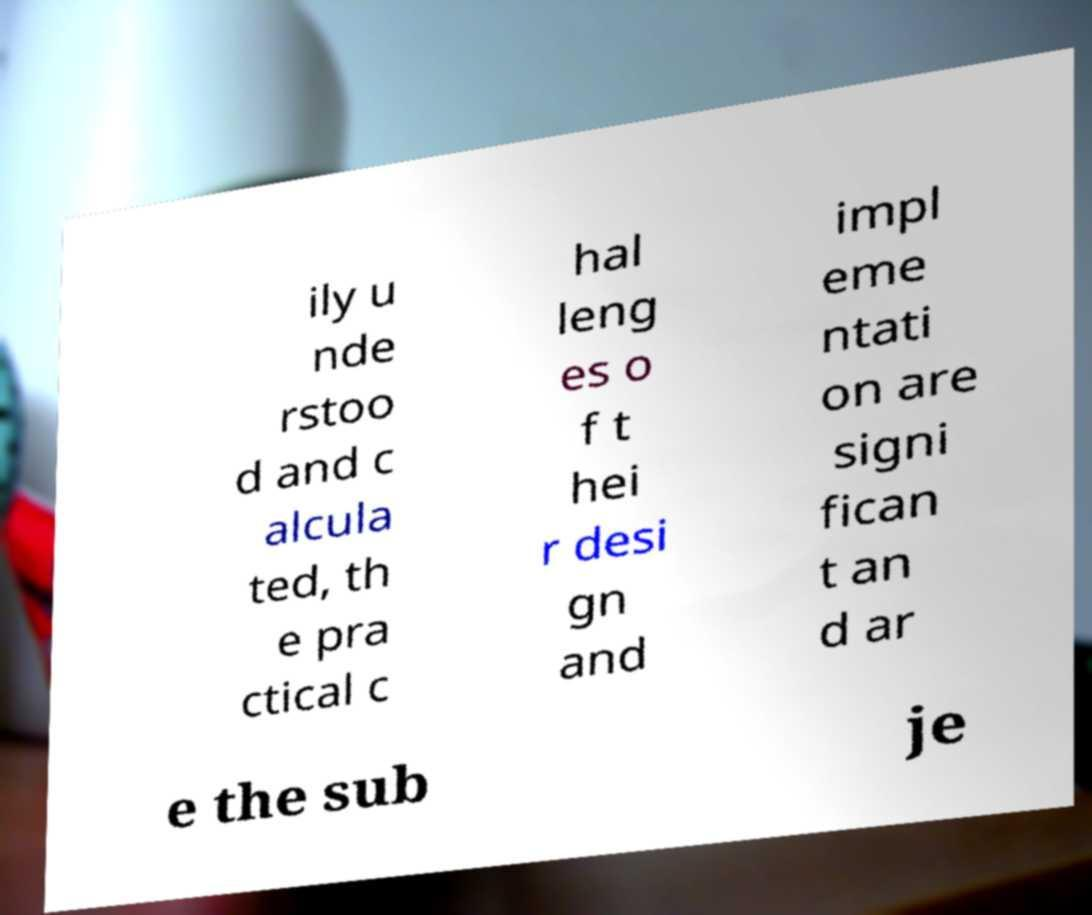For documentation purposes, I need the text within this image transcribed. Could you provide that? ily u nde rstoo d and c alcula ted, th e pra ctical c hal leng es o f t hei r desi gn and impl eme ntati on are signi fican t an d ar e the sub je 